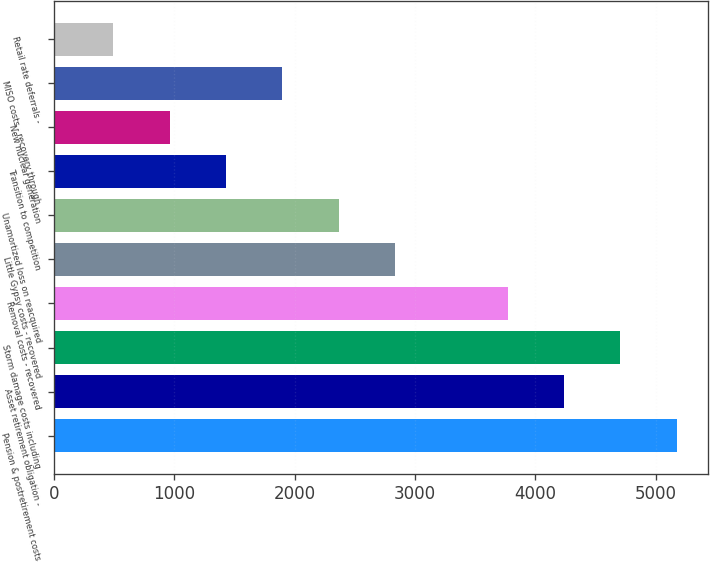<chart> <loc_0><loc_0><loc_500><loc_500><bar_chart><fcel>Pension & postretirement costs<fcel>Asset retirement obligation -<fcel>Storm damage costs including<fcel>Removal costs - recovered<fcel>Little Gypsy costs - recovered<fcel>Unamortized loss on reacquired<fcel>Transition to competition<fcel>New nuclear generation<fcel>MISO costs - recovery through<fcel>Retail rate deferrals -<nl><fcel>5172.45<fcel>4237.15<fcel>4704.8<fcel>3769.5<fcel>2834.2<fcel>2366.55<fcel>1431.25<fcel>963.6<fcel>1898.9<fcel>495.95<nl></chart> 